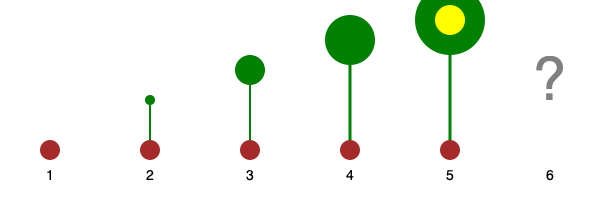In this visual sequence of a plant's growth in a school garden project, what stage would logically come next? To determine the next logical stage in this plant growth sequence, let's analyze the progression:

1. Stage 1: Seed - A brown circle representing a planted seed.
2. Stage 2: Sprout - A small green shoot emerges from the seed.
3. Stage 3: Small plant - The shoot grows taller with a small leaf cluster.
4. Stage 4: Medium plant - The plant continues to grow taller with a larger leaf cluster.
5. Stage 5: Flowering plant - The plant reaches full height with a flower blooming.

The sequence shows the complete life cycle of a flowering plant, from seed to mature, flowering plant. The logical next stage would be the formation of fruit or seed pods, which occurs after pollination of the flower. This stage is crucial for completing the plant's life cycle and ensuring the next generation of plants.

As an elementary school principal, understanding this sequence is valuable for guiding teachers in developing engaging science curricula and garden-based learning projects. It demonstrates the full cycle of plant growth, which is an essential concept in elementary science education.
Answer: Fruit or seed pod formation 